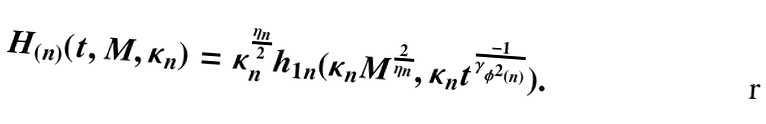<formula> <loc_0><loc_0><loc_500><loc_500>H _ { ( n ) } ( t , M , \kappa _ { n } ) = \kappa _ { n } ^ { \frac { \eta _ { n } } { 2 } } h _ { 1 n } ( \kappa _ { n } M ^ { \frac { 2 } { \eta _ { n } } } , \kappa _ { n } t ^ { \frac { - 1 } { \gamma _ { \phi ^ { 2 } ( n ) } } } ) .</formula> 